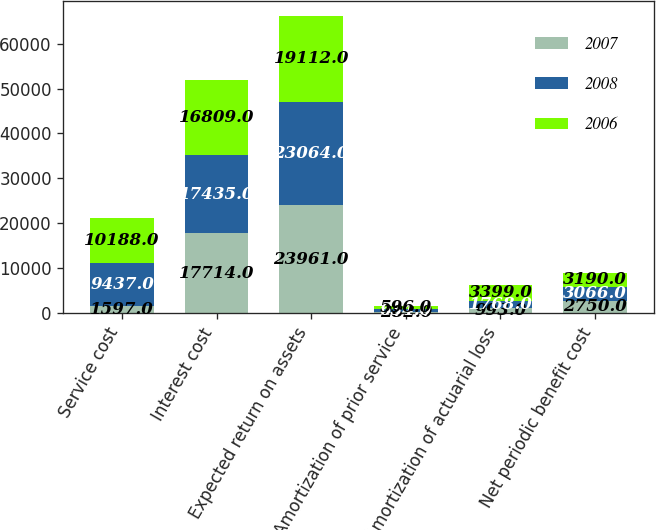Convert chart. <chart><loc_0><loc_0><loc_500><loc_500><stacked_bar_chart><ecel><fcel>Service cost<fcel>Interest cost<fcel>Expected return on assets<fcel>Amortization of prior service<fcel>Amortization of actuarial loss<fcel>Net periodic benefit cost<nl><fcel>2007<fcel>1597<fcel>17714<fcel>23961<fcel>282<fcel>993<fcel>2750<nl><fcel>2008<fcel>9437<fcel>17435<fcel>23064<fcel>634<fcel>1768<fcel>3066<nl><fcel>2006<fcel>10188<fcel>16809<fcel>19112<fcel>596<fcel>3399<fcel>3190<nl></chart> 